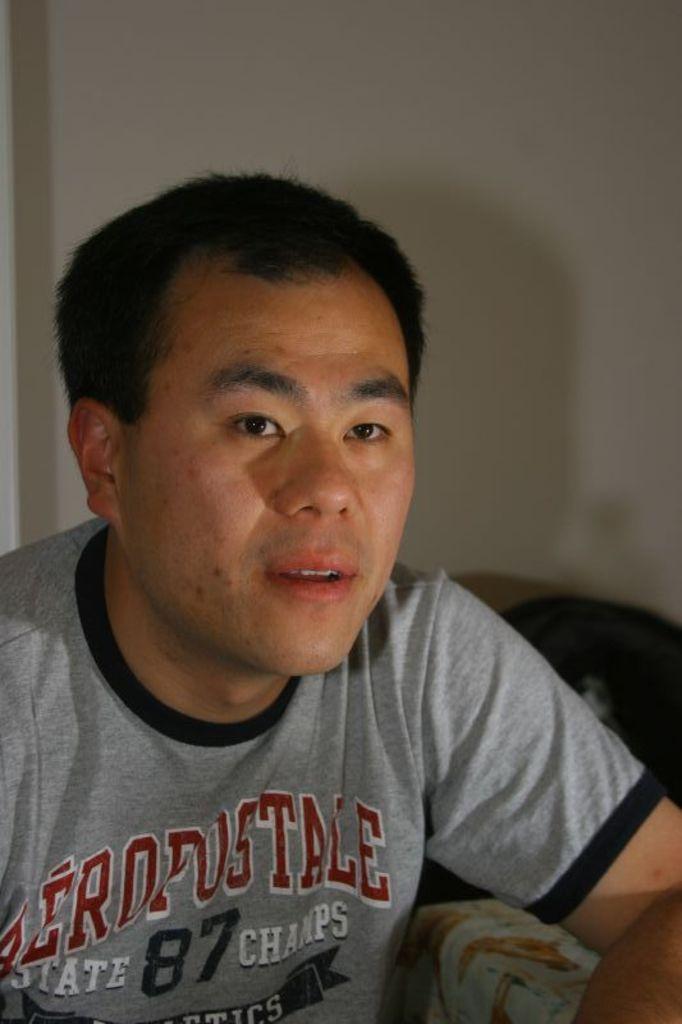Could you give a brief overview of what you see in this image? In this image, we can see a person in front of the wall. This person is wearing clothes. 